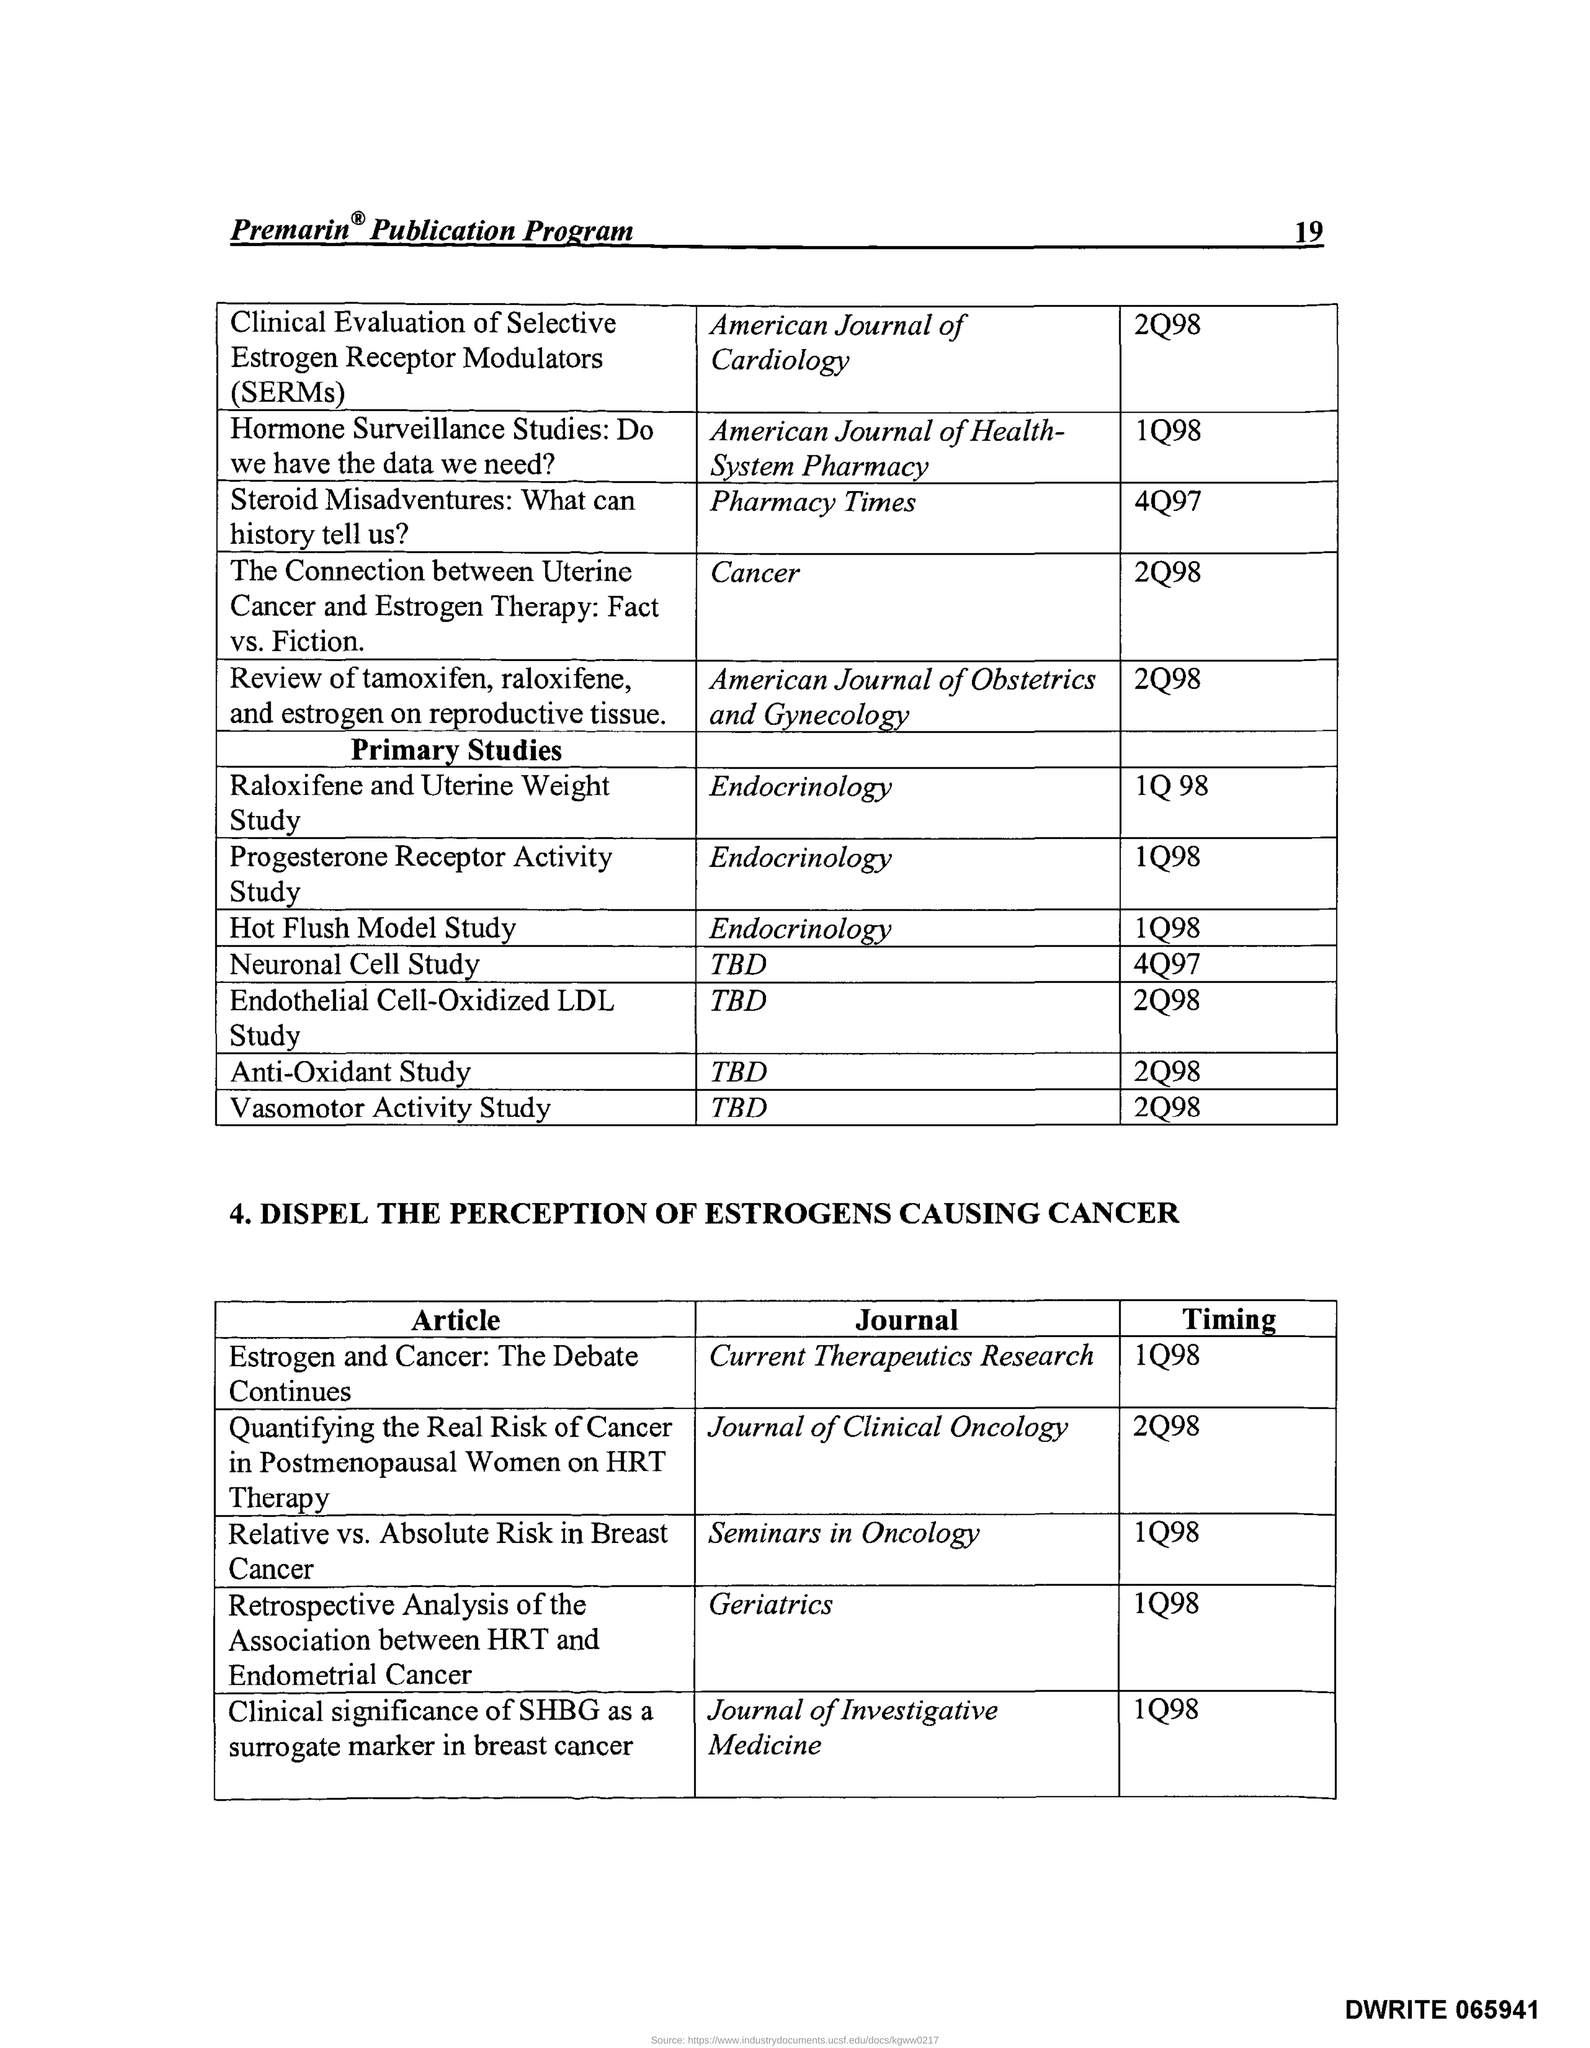What is the Page Number?
Provide a short and direct response. 19. What is the timing of the journal "Geriatrics"?
Offer a very short reply. 1Q98. What is the timing of the journal "Seminars in Oncology"?
Offer a terse response. 1Q98. What is the name of the article in the journal "Current Therapeutics Research"?
Your answer should be compact. Estrogen and Cancer: The Debate Continues. What is the name of the article in the journal ""Seminars in Oncology"?
Give a very brief answer. Relative vs. Absolute Risk in Breast Cancer. 